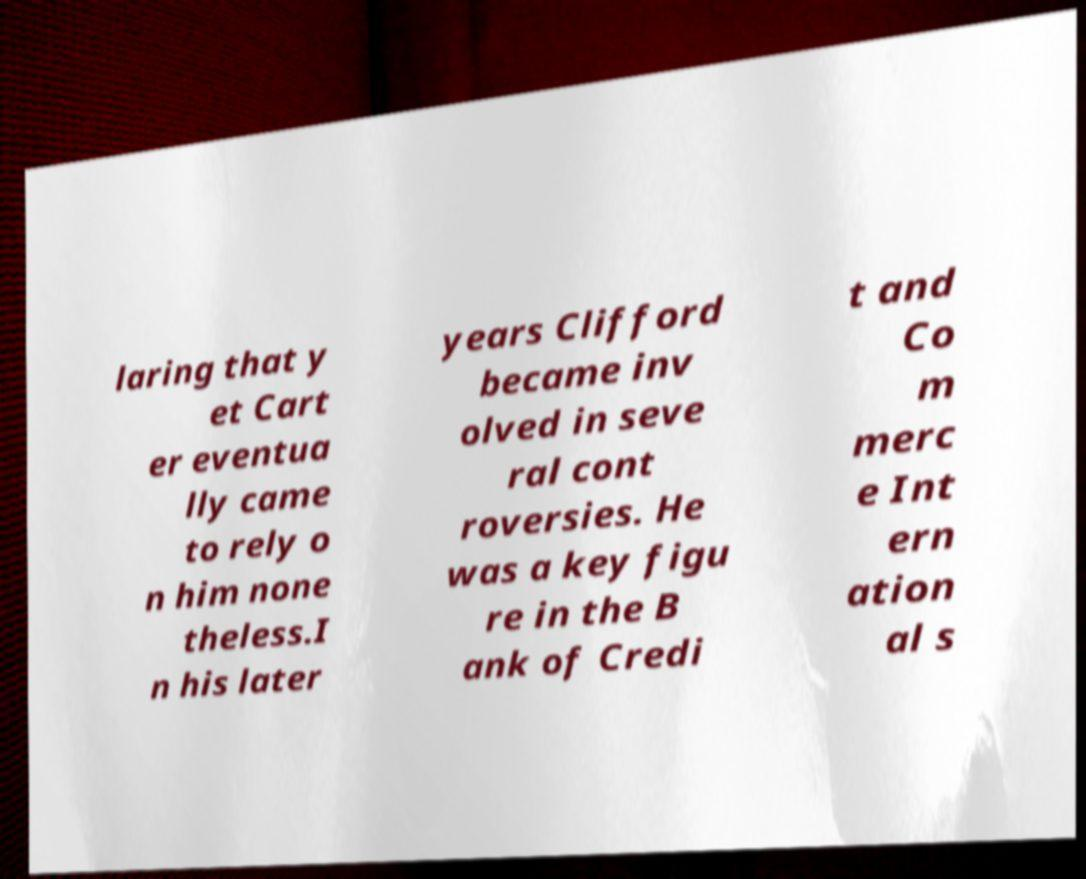Please identify and transcribe the text found in this image. laring that y et Cart er eventua lly came to rely o n him none theless.I n his later years Clifford became inv olved in seve ral cont roversies. He was a key figu re in the B ank of Credi t and Co m merc e Int ern ation al s 